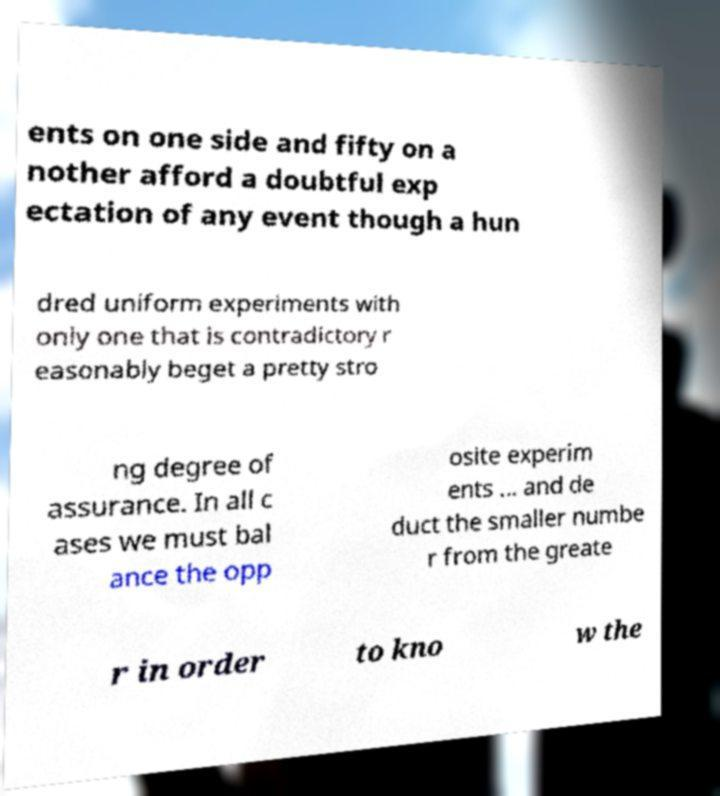Could you extract and type out the text from this image? ents on one side and fifty on a nother afford a doubtful exp ectation of any event though a hun dred uniform experiments with only one that is contradictory r easonably beget a pretty stro ng degree of assurance. In all c ases we must bal ance the opp osite experim ents ... and de duct the smaller numbe r from the greate r in order to kno w the 